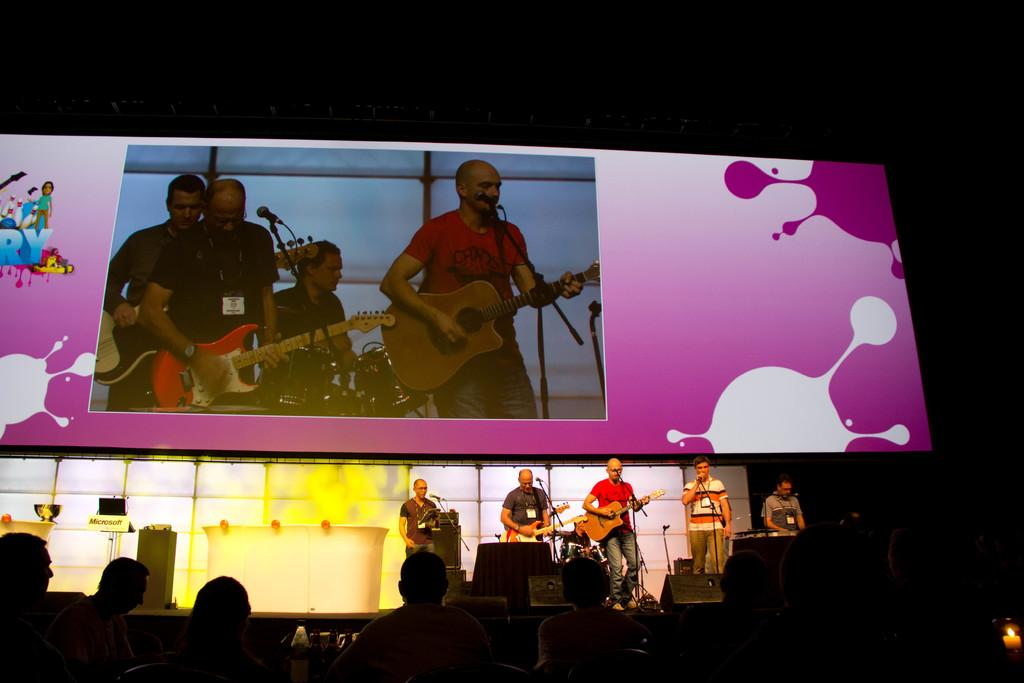What are the men in the image doing? The men in the image are playing guitar and singing a song. Where are the men located in the image? They are on a stage. What can be seen on the stage besides the men? There is a big screen on the stage. What might be used to amplify their voices during the performance? They are in front of a microphone. What type of van is parked near the stage in the image? There is no van present in the image; it only shows the men on stage. How many boundaries are visible in the image? There are no boundaries mentioned or visible in the image. 